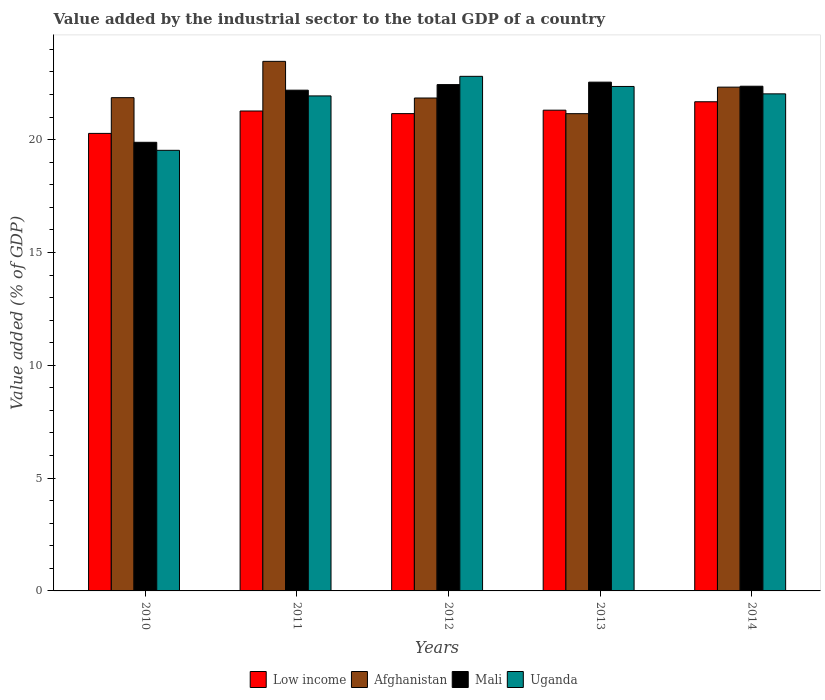How many different coloured bars are there?
Ensure brevity in your answer.  4. How many groups of bars are there?
Make the answer very short. 5. What is the value added by the industrial sector to the total GDP in Uganda in 2014?
Ensure brevity in your answer.  22.03. Across all years, what is the maximum value added by the industrial sector to the total GDP in Afghanistan?
Ensure brevity in your answer.  23.47. Across all years, what is the minimum value added by the industrial sector to the total GDP in Mali?
Ensure brevity in your answer.  19.88. What is the total value added by the industrial sector to the total GDP in Mali in the graph?
Keep it short and to the point. 109.44. What is the difference between the value added by the industrial sector to the total GDP in Low income in 2011 and that in 2014?
Provide a short and direct response. -0.41. What is the difference between the value added by the industrial sector to the total GDP in Low income in 2012 and the value added by the industrial sector to the total GDP in Afghanistan in 2013?
Offer a terse response. 0. What is the average value added by the industrial sector to the total GDP in Uganda per year?
Ensure brevity in your answer.  21.73. In the year 2011, what is the difference between the value added by the industrial sector to the total GDP in Afghanistan and value added by the industrial sector to the total GDP in Mali?
Ensure brevity in your answer.  1.28. What is the ratio of the value added by the industrial sector to the total GDP in Afghanistan in 2013 to that in 2014?
Make the answer very short. 0.95. What is the difference between the highest and the second highest value added by the industrial sector to the total GDP in Low income?
Your answer should be compact. 0.37. What is the difference between the highest and the lowest value added by the industrial sector to the total GDP in Afghanistan?
Your answer should be very brief. 2.32. Is the sum of the value added by the industrial sector to the total GDP in Afghanistan in 2010 and 2012 greater than the maximum value added by the industrial sector to the total GDP in Mali across all years?
Ensure brevity in your answer.  Yes. What does the 3rd bar from the left in 2012 represents?
Make the answer very short. Mali. What does the 2nd bar from the right in 2010 represents?
Ensure brevity in your answer.  Mali. Are all the bars in the graph horizontal?
Make the answer very short. No. How many years are there in the graph?
Your answer should be compact. 5. What is the difference between two consecutive major ticks on the Y-axis?
Offer a very short reply. 5. What is the title of the graph?
Provide a short and direct response. Value added by the industrial sector to the total GDP of a country. What is the label or title of the X-axis?
Offer a terse response. Years. What is the label or title of the Y-axis?
Your answer should be very brief. Value added (% of GDP). What is the Value added (% of GDP) in Low income in 2010?
Provide a succinct answer. 20.28. What is the Value added (% of GDP) of Afghanistan in 2010?
Your response must be concise. 21.86. What is the Value added (% of GDP) in Mali in 2010?
Make the answer very short. 19.88. What is the Value added (% of GDP) of Uganda in 2010?
Make the answer very short. 19.53. What is the Value added (% of GDP) of Low income in 2011?
Your response must be concise. 21.27. What is the Value added (% of GDP) of Afghanistan in 2011?
Offer a terse response. 23.47. What is the Value added (% of GDP) of Mali in 2011?
Give a very brief answer. 22.19. What is the Value added (% of GDP) of Uganda in 2011?
Offer a very short reply. 21.94. What is the Value added (% of GDP) in Low income in 2012?
Your response must be concise. 21.16. What is the Value added (% of GDP) of Afghanistan in 2012?
Provide a short and direct response. 21.85. What is the Value added (% of GDP) in Mali in 2012?
Provide a short and direct response. 22.44. What is the Value added (% of GDP) in Uganda in 2012?
Make the answer very short. 22.81. What is the Value added (% of GDP) in Low income in 2013?
Offer a very short reply. 21.31. What is the Value added (% of GDP) in Afghanistan in 2013?
Keep it short and to the point. 21.15. What is the Value added (% of GDP) of Mali in 2013?
Your answer should be compact. 22.55. What is the Value added (% of GDP) in Uganda in 2013?
Offer a very short reply. 22.36. What is the Value added (% of GDP) of Low income in 2014?
Your answer should be very brief. 21.68. What is the Value added (% of GDP) of Afghanistan in 2014?
Your answer should be compact. 22.33. What is the Value added (% of GDP) in Mali in 2014?
Provide a short and direct response. 22.37. What is the Value added (% of GDP) in Uganda in 2014?
Your answer should be very brief. 22.03. Across all years, what is the maximum Value added (% of GDP) in Low income?
Give a very brief answer. 21.68. Across all years, what is the maximum Value added (% of GDP) of Afghanistan?
Give a very brief answer. 23.47. Across all years, what is the maximum Value added (% of GDP) of Mali?
Provide a succinct answer. 22.55. Across all years, what is the maximum Value added (% of GDP) of Uganda?
Give a very brief answer. 22.81. Across all years, what is the minimum Value added (% of GDP) in Low income?
Your answer should be very brief. 20.28. Across all years, what is the minimum Value added (% of GDP) in Afghanistan?
Your answer should be compact. 21.15. Across all years, what is the minimum Value added (% of GDP) of Mali?
Ensure brevity in your answer.  19.88. Across all years, what is the minimum Value added (% of GDP) of Uganda?
Provide a succinct answer. 19.53. What is the total Value added (% of GDP) of Low income in the graph?
Give a very brief answer. 105.69. What is the total Value added (% of GDP) of Afghanistan in the graph?
Your answer should be very brief. 110.66. What is the total Value added (% of GDP) in Mali in the graph?
Keep it short and to the point. 109.44. What is the total Value added (% of GDP) of Uganda in the graph?
Provide a short and direct response. 108.67. What is the difference between the Value added (% of GDP) in Low income in 2010 and that in 2011?
Give a very brief answer. -0.99. What is the difference between the Value added (% of GDP) of Afghanistan in 2010 and that in 2011?
Your answer should be very brief. -1.61. What is the difference between the Value added (% of GDP) of Mali in 2010 and that in 2011?
Offer a very short reply. -2.31. What is the difference between the Value added (% of GDP) of Uganda in 2010 and that in 2011?
Ensure brevity in your answer.  -2.41. What is the difference between the Value added (% of GDP) in Low income in 2010 and that in 2012?
Your response must be concise. -0.88. What is the difference between the Value added (% of GDP) of Afghanistan in 2010 and that in 2012?
Provide a succinct answer. 0.01. What is the difference between the Value added (% of GDP) of Mali in 2010 and that in 2012?
Provide a short and direct response. -2.56. What is the difference between the Value added (% of GDP) in Uganda in 2010 and that in 2012?
Your answer should be compact. -3.28. What is the difference between the Value added (% of GDP) of Low income in 2010 and that in 2013?
Your answer should be compact. -1.03. What is the difference between the Value added (% of GDP) of Afghanistan in 2010 and that in 2013?
Ensure brevity in your answer.  0.71. What is the difference between the Value added (% of GDP) in Mali in 2010 and that in 2013?
Give a very brief answer. -2.67. What is the difference between the Value added (% of GDP) of Uganda in 2010 and that in 2013?
Keep it short and to the point. -2.83. What is the difference between the Value added (% of GDP) of Low income in 2010 and that in 2014?
Provide a short and direct response. -1.4. What is the difference between the Value added (% of GDP) of Afghanistan in 2010 and that in 2014?
Provide a succinct answer. -0.47. What is the difference between the Value added (% of GDP) of Mali in 2010 and that in 2014?
Offer a terse response. -2.49. What is the difference between the Value added (% of GDP) in Uganda in 2010 and that in 2014?
Provide a succinct answer. -2.5. What is the difference between the Value added (% of GDP) of Low income in 2011 and that in 2012?
Your answer should be very brief. 0.12. What is the difference between the Value added (% of GDP) in Afghanistan in 2011 and that in 2012?
Offer a terse response. 1.62. What is the difference between the Value added (% of GDP) in Mali in 2011 and that in 2012?
Offer a terse response. -0.25. What is the difference between the Value added (% of GDP) of Uganda in 2011 and that in 2012?
Give a very brief answer. -0.87. What is the difference between the Value added (% of GDP) of Low income in 2011 and that in 2013?
Offer a terse response. -0.04. What is the difference between the Value added (% of GDP) of Afghanistan in 2011 and that in 2013?
Your answer should be compact. 2.32. What is the difference between the Value added (% of GDP) in Mali in 2011 and that in 2013?
Keep it short and to the point. -0.36. What is the difference between the Value added (% of GDP) in Uganda in 2011 and that in 2013?
Give a very brief answer. -0.42. What is the difference between the Value added (% of GDP) in Low income in 2011 and that in 2014?
Offer a very short reply. -0.41. What is the difference between the Value added (% of GDP) in Afghanistan in 2011 and that in 2014?
Offer a terse response. 1.14. What is the difference between the Value added (% of GDP) in Mali in 2011 and that in 2014?
Provide a short and direct response. -0.18. What is the difference between the Value added (% of GDP) in Uganda in 2011 and that in 2014?
Make the answer very short. -0.09. What is the difference between the Value added (% of GDP) in Low income in 2012 and that in 2013?
Your answer should be very brief. -0.15. What is the difference between the Value added (% of GDP) of Afghanistan in 2012 and that in 2013?
Keep it short and to the point. 0.69. What is the difference between the Value added (% of GDP) of Mali in 2012 and that in 2013?
Make the answer very short. -0.11. What is the difference between the Value added (% of GDP) of Uganda in 2012 and that in 2013?
Make the answer very short. 0.45. What is the difference between the Value added (% of GDP) of Low income in 2012 and that in 2014?
Offer a very short reply. -0.53. What is the difference between the Value added (% of GDP) in Afghanistan in 2012 and that in 2014?
Provide a short and direct response. -0.48. What is the difference between the Value added (% of GDP) of Mali in 2012 and that in 2014?
Make the answer very short. 0.07. What is the difference between the Value added (% of GDP) in Uganda in 2012 and that in 2014?
Ensure brevity in your answer.  0.78. What is the difference between the Value added (% of GDP) in Low income in 2013 and that in 2014?
Offer a terse response. -0.37. What is the difference between the Value added (% of GDP) of Afghanistan in 2013 and that in 2014?
Provide a short and direct response. -1.18. What is the difference between the Value added (% of GDP) of Mali in 2013 and that in 2014?
Make the answer very short. 0.18. What is the difference between the Value added (% of GDP) of Uganda in 2013 and that in 2014?
Your answer should be compact. 0.33. What is the difference between the Value added (% of GDP) of Low income in 2010 and the Value added (% of GDP) of Afghanistan in 2011?
Make the answer very short. -3.19. What is the difference between the Value added (% of GDP) of Low income in 2010 and the Value added (% of GDP) of Mali in 2011?
Offer a terse response. -1.92. What is the difference between the Value added (% of GDP) of Low income in 2010 and the Value added (% of GDP) of Uganda in 2011?
Offer a very short reply. -1.66. What is the difference between the Value added (% of GDP) of Afghanistan in 2010 and the Value added (% of GDP) of Mali in 2011?
Ensure brevity in your answer.  -0.33. What is the difference between the Value added (% of GDP) in Afghanistan in 2010 and the Value added (% of GDP) in Uganda in 2011?
Your answer should be very brief. -0.08. What is the difference between the Value added (% of GDP) of Mali in 2010 and the Value added (% of GDP) of Uganda in 2011?
Your answer should be very brief. -2.06. What is the difference between the Value added (% of GDP) of Low income in 2010 and the Value added (% of GDP) of Afghanistan in 2012?
Provide a short and direct response. -1.57. What is the difference between the Value added (% of GDP) of Low income in 2010 and the Value added (% of GDP) of Mali in 2012?
Your answer should be very brief. -2.16. What is the difference between the Value added (% of GDP) in Low income in 2010 and the Value added (% of GDP) in Uganda in 2012?
Ensure brevity in your answer.  -2.53. What is the difference between the Value added (% of GDP) in Afghanistan in 2010 and the Value added (% of GDP) in Mali in 2012?
Ensure brevity in your answer.  -0.58. What is the difference between the Value added (% of GDP) of Afghanistan in 2010 and the Value added (% of GDP) of Uganda in 2012?
Your answer should be very brief. -0.95. What is the difference between the Value added (% of GDP) of Mali in 2010 and the Value added (% of GDP) of Uganda in 2012?
Ensure brevity in your answer.  -2.92. What is the difference between the Value added (% of GDP) of Low income in 2010 and the Value added (% of GDP) of Afghanistan in 2013?
Offer a very short reply. -0.87. What is the difference between the Value added (% of GDP) of Low income in 2010 and the Value added (% of GDP) of Mali in 2013?
Give a very brief answer. -2.27. What is the difference between the Value added (% of GDP) in Low income in 2010 and the Value added (% of GDP) in Uganda in 2013?
Your answer should be compact. -2.08. What is the difference between the Value added (% of GDP) of Afghanistan in 2010 and the Value added (% of GDP) of Mali in 2013?
Make the answer very short. -0.69. What is the difference between the Value added (% of GDP) in Afghanistan in 2010 and the Value added (% of GDP) in Uganda in 2013?
Give a very brief answer. -0.5. What is the difference between the Value added (% of GDP) of Mali in 2010 and the Value added (% of GDP) of Uganda in 2013?
Provide a succinct answer. -2.48. What is the difference between the Value added (% of GDP) of Low income in 2010 and the Value added (% of GDP) of Afghanistan in 2014?
Provide a short and direct response. -2.05. What is the difference between the Value added (% of GDP) of Low income in 2010 and the Value added (% of GDP) of Mali in 2014?
Keep it short and to the point. -2.09. What is the difference between the Value added (% of GDP) of Low income in 2010 and the Value added (% of GDP) of Uganda in 2014?
Give a very brief answer. -1.75. What is the difference between the Value added (% of GDP) in Afghanistan in 2010 and the Value added (% of GDP) in Mali in 2014?
Your answer should be compact. -0.51. What is the difference between the Value added (% of GDP) of Afghanistan in 2010 and the Value added (% of GDP) of Uganda in 2014?
Your response must be concise. -0.17. What is the difference between the Value added (% of GDP) of Mali in 2010 and the Value added (% of GDP) of Uganda in 2014?
Offer a very short reply. -2.15. What is the difference between the Value added (% of GDP) in Low income in 2011 and the Value added (% of GDP) in Afghanistan in 2012?
Keep it short and to the point. -0.58. What is the difference between the Value added (% of GDP) in Low income in 2011 and the Value added (% of GDP) in Mali in 2012?
Provide a short and direct response. -1.17. What is the difference between the Value added (% of GDP) of Low income in 2011 and the Value added (% of GDP) of Uganda in 2012?
Provide a succinct answer. -1.54. What is the difference between the Value added (% of GDP) of Afghanistan in 2011 and the Value added (% of GDP) of Mali in 2012?
Your answer should be very brief. 1.03. What is the difference between the Value added (% of GDP) of Afghanistan in 2011 and the Value added (% of GDP) of Uganda in 2012?
Make the answer very short. 0.66. What is the difference between the Value added (% of GDP) in Mali in 2011 and the Value added (% of GDP) in Uganda in 2012?
Provide a short and direct response. -0.61. What is the difference between the Value added (% of GDP) in Low income in 2011 and the Value added (% of GDP) in Afghanistan in 2013?
Your answer should be very brief. 0.12. What is the difference between the Value added (% of GDP) in Low income in 2011 and the Value added (% of GDP) in Mali in 2013?
Provide a short and direct response. -1.28. What is the difference between the Value added (% of GDP) of Low income in 2011 and the Value added (% of GDP) of Uganda in 2013?
Provide a short and direct response. -1.09. What is the difference between the Value added (% of GDP) in Afghanistan in 2011 and the Value added (% of GDP) in Mali in 2013?
Your response must be concise. 0.92. What is the difference between the Value added (% of GDP) of Afghanistan in 2011 and the Value added (% of GDP) of Uganda in 2013?
Your answer should be compact. 1.11. What is the difference between the Value added (% of GDP) in Mali in 2011 and the Value added (% of GDP) in Uganda in 2013?
Your answer should be compact. -0.16. What is the difference between the Value added (% of GDP) of Low income in 2011 and the Value added (% of GDP) of Afghanistan in 2014?
Offer a terse response. -1.06. What is the difference between the Value added (% of GDP) of Low income in 2011 and the Value added (% of GDP) of Mali in 2014?
Ensure brevity in your answer.  -1.1. What is the difference between the Value added (% of GDP) of Low income in 2011 and the Value added (% of GDP) of Uganda in 2014?
Offer a terse response. -0.76. What is the difference between the Value added (% of GDP) in Afghanistan in 2011 and the Value added (% of GDP) in Mali in 2014?
Keep it short and to the point. 1.1. What is the difference between the Value added (% of GDP) in Afghanistan in 2011 and the Value added (% of GDP) in Uganda in 2014?
Offer a very short reply. 1.44. What is the difference between the Value added (% of GDP) in Mali in 2011 and the Value added (% of GDP) in Uganda in 2014?
Make the answer very short. 0.16. What is the difference between the Value added (% of GDP) in Low income in 2012 and the Value added (% of GDP) in Afghanistan in 2013?
Offer a terse response. 0. What is the difference between the Value added (% of GDP) in Low income in 2012 and the Value added (% of GDP) in Mali in 2013?
Your answer should be compact. -1.4. What is the difference between the Value added (% of GDP) of Low income in 2012 and the Value added (% of GDP) of Uganda in 2013?
Your answer should be compact. -1.2. What is the difference between the Value added (% of GDP) in Afghanistan in 2012 and the Value added (% of GDP) in Mali in 2013?
Offer a very short reply. -0.7. What is the difference between the Value added (% of GDP) of Afghanistan in 2012 and the Value added (% of GDP) of Uganda in 2013?
Make the answer very short. -0.51. What is the difference between the Value added (% of GDP) in Mali in 2012 and the Value added (% of GDP) in Uganda in 2013?
Your answer should be compact. 0.08. What is the difference between the Value added (% of GDP) in Low income in 2012 and the Value added (% of GDP) in Afghanistan in 2014?
Ensure brevity in your answer.  -1.17. What is the difference between the Value added (% of GDP) in Low income in 2012 and the Value added (% of GDP) in Mali in 2014?
Offer a terse response. -1.21. What is the difference between the Value added (% of GDP) of Low income in 2012 and the Value added (% of GDP) of Uganda in 2014?
Your answer should be compact. -0.88. What is the difference between the Value added (% of GDP) of Afghanistan in 2012 and the Value added (% of GDP) of Mali in 2014?
Provide a short and direct response. -0.52. What is the difference between the Value added (% of GDP) in Afghanistan in 2012 and the Value added (% of GDP) in Uganda in 2014?
Ensure brevity in your answer.  -0.18. What is the difference between the Value added (% of GDP) of Mali in 2012 and the Value added (% of GDP) of Uganda in 2014?
Your answer should be compact. 0.41. What is the difference between the Value added (% of GDP) in Low income in 2013 and the Value added (% of GDP) in Afghanistan in 2014?
Provide a short and direct response. -1.02. What is the difference between the Value added (% of GDP) in Low income in 2013 and the Value added (% of GDP) in Mali in 2014?
Provide a succinct answer. -1.06. What is the difference between the Value added (% of GDP) in Low income in 2013 and the Value added (% of GDP) in Uganda in 2014?
Provide a succinct answer. -0.72. What is the difference between the Value added (% of GDP) of Afghanistan in 2013 and the Value added (% of GDP) of Mali in 2014?
Your response must be concise. -1.22. What is the difference between the Value added (% of GDP) in Afghanistan in 2013 and the Value added (% of GDP) in Uganda in 2014?
Offer a very short reply. -0.88. What is the difference between the Value added (% of GDP) in Mali in 2013 and the Value added (% of GDP) in Uganda in 2014?
Give a very brief answer. 0.52. What is the average Value added (% of GDP) in Low income per year?
Your response must be concise. 21.14. What is the average Value added (% of GDP) in Afghanistan per year?
Keep it short and to the point. 22.13. What is the average Value added (% of GDP) of Mali per year?
Give a very brief answer. 21.89. What is the average Value added (% of GDP) of Uganda per year?
Provide a short and direct response. 21.73. In the year 2010, what is the difference between the Value added (% of GDP) in Low income and Value added (% of GDP) in Afghanistan?
Offer a very short reply. -1.58. In the year 2010, what is the difference between the Value added (% of GDP) of Low income and Value added (% of GDP) of Mali?
Provide a short and direct response. 0.39. In the year 2010, what is the difference between the Value added (% of GDP) of Afghanistan and Value added (% of GDP) of Mali?
Keep it short and to the point. 1.98. In the year 2010, what is the difference between the Value added (% of GDP) in Afghanistan and Value added (% of GDP) in Uganda?
Your answer should be compact. 2.33. In the year 2010, what is the difference between the Value added (% of GDP) in Mali and Value added (% of GDP) in Uganda?
Your answer should be very brief. 0.36. In the year 2011, what is the difference between the Value added (% of GDP) of Low income and Value added (% of GDP) of Afghanistan?
Make the answer very short. -2.2. In the year 2011, what is the difference between the Value added (% of GDP) in Low income and Value added (% of GDP) in Mali?
Your answer should be very brief. -0.92. In the year 2011, what is the difference between the Value added (% of GDP) of Low income and Value added (% of GDP) of Uganda?
Offer a terse response. -0.67. In the year 2011, what is the difference between the Value added (% of GDP) of Afghanistan and Value added (% of GDP) of Mali?
Your answer should be compact. 1.28. In the year 2011, what is the difference between the Value added (% of GDP) in Afghanistan and Value added (% of GDP) in Uganda?
Ensure brevity in your answer.  1.53. In the year 2011, what is the difference between the Value added (% of GDP) in Mali and Value added (% of GDP) in Uganda?
Keep it short and to the point. 0.25. In the year 2012, what is the difference between the Value added (% of GDP) of Low income and Value added (% of GDP) of Afghanistan?
Provide a succinct answer. -0.69. In the year 2012, what is the difference between the Value added (% of GDP) of Low income and Value added (% of GDP) of Mali?
Your response must be concise. -1.29. In the year 2012, what is the difference between the Value added (% of GDP) in Low income and Value added (% of GDP) in Uganda?
Your answer should be compact. -1.65. In the year 2012, what is the difference between the Value added (% of GDP) of Afghanistan and Value added (% of GDP) of Mali?
Your answer should be compact. -0.59. In the year 2012, what is the difference between the Value added (% of GDP) of Afghanistan and Value added (% of GDP) of Uganda?
Make the answer very short. -0.96. In the year 2012, what is the difference between the Value added (% of GDP) of Mali and Value added (% of GDP) of Uganda?
Make the answer very short. -0.37. In the year 2013, what is the difference between the Value added (% of GDP) of Low income and Value added (% of GDP) of Afghanistan?
Your answer should be very brief. 0.15. In the year 2013, what is the difference between the Value added (% of GDP) of Low income and Value added (% of GDP) of Mali?
Provide a succinct answer. -1.24. In the year 2013, what is the difference between the Value added (% of GDP) in Low income and Value added (% of GDP) in Uganda?
Offer a very short reply. -1.05. In the year 2013, what is the difference between the Value added (% of GDP) of Afghanistan and Value added (% of GDP) of Mali?
Your response must be concise. -1.4. In the year 2013, what is the difference between the Value added (% of GDP) of Afghanistan and Value added (% of GDP) of Uganda?
Provide a succinct answer. -1.21. In the year 2013, what is the difference between the Value added (% of GDP) in Mali and Value added (% of GDP) in Uganda?
Offer a terse response. 0.19. In the year 2014, what is the difference between the Value added (% of GDP) of Low income and Value added (% of GDP) of Afghanistan?
Your answer should be very brief. -0.65. In the year 2014, what is the difference between the Value added (% of GDP) in Low income and Value added (% of GDP) in Mali?
Offer a very short reply. -0.69. In the year 2014, what is the difference between the Value added (% of GDP) of Low income and Value added (% of GDP) of Uganda?
Your answer should be compact. -0.35. In the year 2014, what is the difference between the Value added (% of GDP) in Afghanistan and Value added (% of GDP) in Mali?
Your answer should be compact. -0.04. In the year 2014, what is the difference between the Value added (% of GDP) of Afghanistan and Value added (% of GDP) of Uganda?
Keep it short and to the point. 0.3. In the year 2014, what is the difference between the Value added (% of GDP) in Mali and Value added (% of GDP) in Uganda?
Keep it short and to the point. 0.34. What is the ratio of the Value added (% of GDP) in Low income in 2010 to that in 2011?
Provide a short and direct response. 0.95. What is the ratio of the Value added (% of GDP) of Afghanistan in 2010 to that in 2011?
Provide a succinct answer. 0.93. What is the ratio of the Value added (% of GDP) in Mali in 2010 to that in 2011?
Make the answer very short. 0.9. What is the ratio of the Value added (% of GDP) of Uganda in 2010 to that in 2011?
Provide a short and direct response. 0.89. What is the ratio of the Value added (% of GDP) of Low income in 2010 to that in 2012?
Ensure brevity in your answer.  0.96. What is the ratio of the Value added (% of GDP) in Afghanistan in 2010 to that in 2012?
Give a very brief answer. 1. What is the ratio of the Value added (% of GDP) in Mali in 2010 to that in 2012?
Your response must be concise. 0.89. What is the ratio of the Value added (% of GDP) of Uganda in 2010 to that in 2012?
Your answer should be very brief. 0.86. What is the ratio of the Value added (% of GDP) of Low income in 2010 to that in 2013?
Offer a very short reply. 0.95. What is the ratio of the Value added (% of GDP) in Afghanistan in 2010 to that in 2013?
Your response must be concise. 1.03. What is the ratio of the Value added (% of GDP) in Mali in 2010 to that in 2013?
Make the answer very short. 0.88. What is the ratio of the Value added (% of GDP) in Uganda in 2010 to that in 2013?
Your answer should be very brief. 0.87. What is the ratio of the Value added (% of GDP) in Low income in 2010 to that in 2014?
Your response must be concise. 0.94. What is the ratio of the Value added (% of GDP) in Afghanistan in 2010 to that in 2014?
Your response must be concise. 0.98. What is the ratio of the Value added (% of GDP) of Uganda in 2010 to that in 2014?
Your answer should be compact. 0.89. What is the ratio of the Value added (% of GDP) of Afghanistan in 2011 to that in 2012?
Your response must be concise. 1.07. What is the ratio of the Value added (% of GDP) in Uganda in 2011 to that in 2012?
Keep it short and to the point. 0.96. What is the ratio of the Value added (% of GDP) of Low income in 2011 to that in 2013?
Give a very brief answer. 1. What is the ratio of the Value added (% of GDP) of Afghanistan in 2011 to that in 2013?
Offer a very short reply. 1.11. What is the ratio of the Value added (% of GDP) in Mali in 2011 to that in 2013?
Offer a very short reply. 0.98. What is the ratio of the Value added (% of GDP) of Uganda in 2011 to that in 2013?
Offer a very short reply. 0.98. What is the ratio of the Value added (% of GDP) in Low income in 2011 to that in 2014?
Your answer should be compact. 0.98. What is the ratio of the Value added (% of GDP) of Afghanistan in 2011 to that in 2014?
Ensure brevity in your answer.  1.05. What is the ratio of the Value added (% of GDP) in Afghanistan in 2012 to that in 2013?
Provide a short and direct response. 1.03. What is the ratio of the Value added (% of GDP) in Mali in 2012 to that in 2013?
Keep it short and to the point. 1. What is the ratio of the Value added (% of GDP) in Uganda in 2012 to that in 2013?
Your response must be concise. 1.02. What is the ratio of the Value added (% of GDP) of Low income in 2012 to that in 2014?
Your response must be concise. 0.98. What is the ratio of the Value added (% of GDP) of Afghanistan in 2012 to that in 2014?
Offer a very short reply. 0.98. What is the ratio of the Value added (% of GDP) of Mali in 2012 to that in 2014?
Offer a terse response. 1. What is the ratio of the Value added (% of GDP) in Uganda in 2012 to that in 2014?
Keep it short and to the point. 1.04. What is the ratio of the Value added (% of GDP) of Low income in 2013 to that in 2014?
Provide a succinct answer. 0.98. What is the ratio of the Value added (% of GDP) in Afghanistan in 2013 to that in 2014?
Offer a terse response. 0.95. What is the ratio of the Value added (% of GDP) of Uganda in 2013 to that in 2014?
Ensure brevity in your answer.  1.01. What is the difference between the highest and the second highest Value added (% of GDP) in Low income?
Offer a terse response. 0.37. What is the difference between the highest and the second highest Value added (% of GDP) of Afghanistan?
Give a very brief answer. 1.14. What is the difference between the highest and the second highest Value added (% of GDP) in Mali?
Give a very brief answer. 0.11. What is the difference between the highest and the second highest Value added (% of GDP) in Uganda?
Your answer should be very brief. 0.45. What is the difference between the highest and the lowest Value added (% of GDP) in Low income?
Keep it short and to the point. 1.4. What is the difference between the highest and the lowest Value added (% of GDP) of Afghanistan?
Your answer should be compact. 2.32. What is the difference between the highest and the lowest Value added (% of GDP) of Mali?
Provide a succinct answer. 2.67. What is the difference between the highest and the lowest Value added (% of GDP) in Uganda?
Keep it short and to the point. 3.28. 